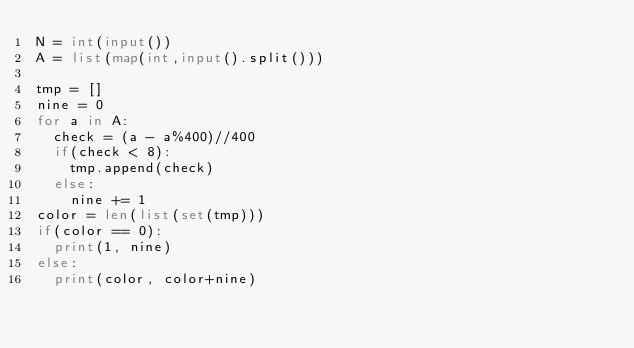Convert code to text. <code><loc_0><loc_0><loc_500><loc_500><_Python_>N = int(input())
A = list(map(int,input().split()))

tmp = []
nine = 0
for a in A:
  check = (a - a%400)//400
  if(check < 8):
    tmp.append(check)
  else:
    nine += 1
color = len(list(set(tmp)))
if(color == 0):
  print(1, nine)
else:
  print(color, color+nine)</code> 